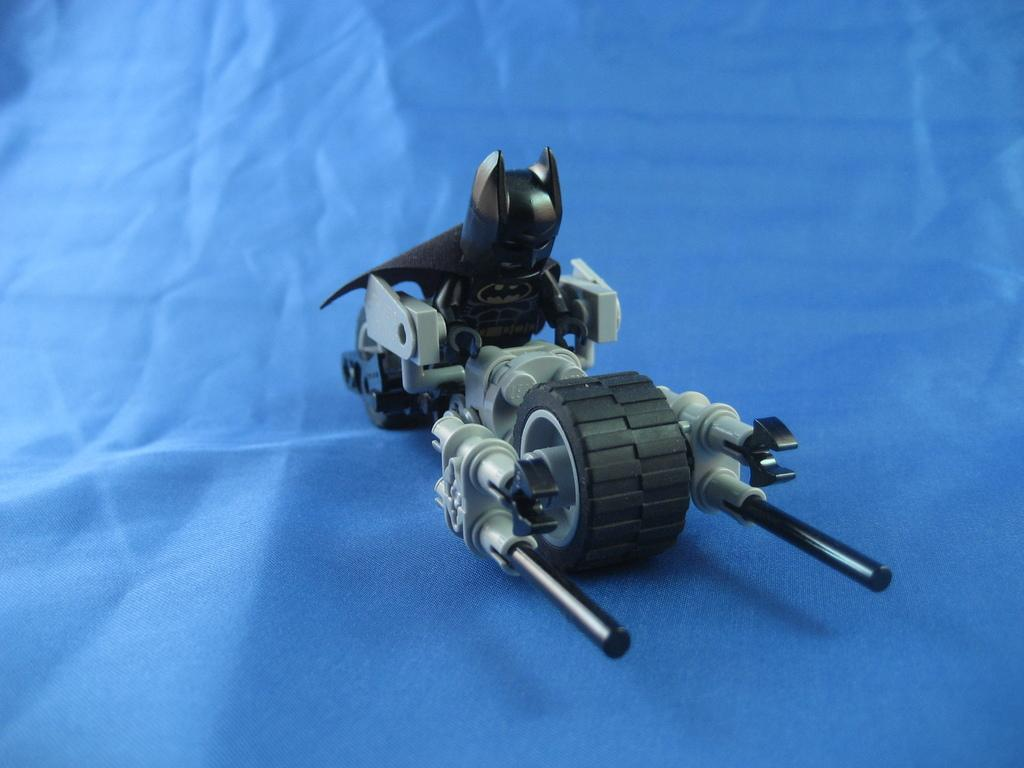What type of toy is depicted in the image? There is a Lego toy of Batman in the image. What color is the blue object in the image? The blue object in the image is not specified, so we cannot determine its color. How does the seat in the image contribute to the hearing of the Lego toy of Batman? There is no seat present in the image, and the Lego toy of Batman does not have the ability to hear. 